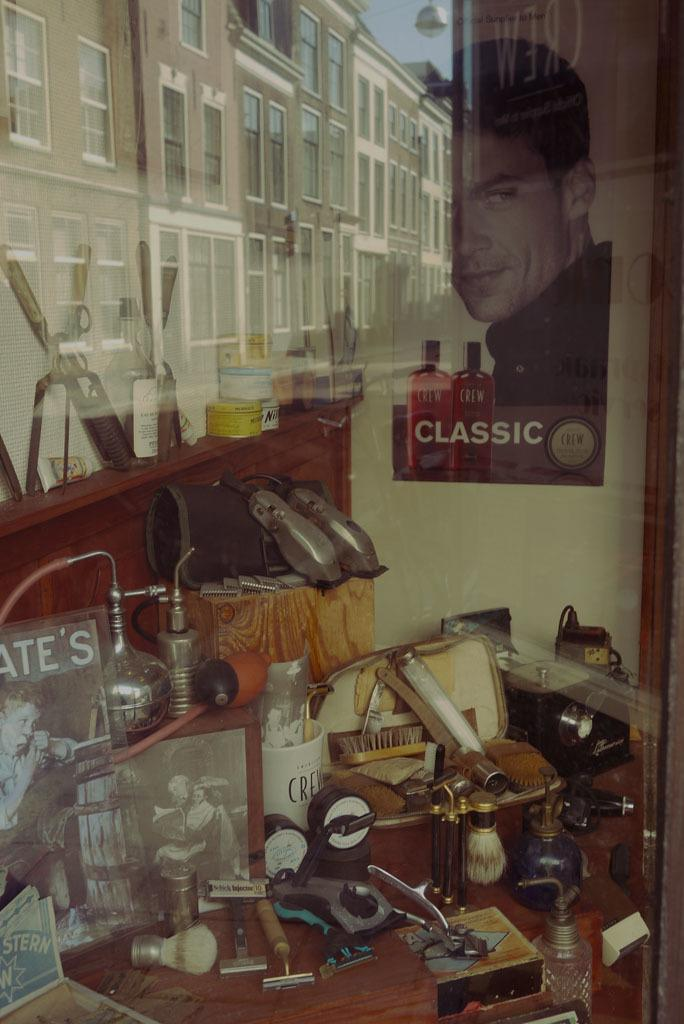<image>
Summarize the visual content of the image. A poster for Crew Classic features a smiling man with dark hair. 